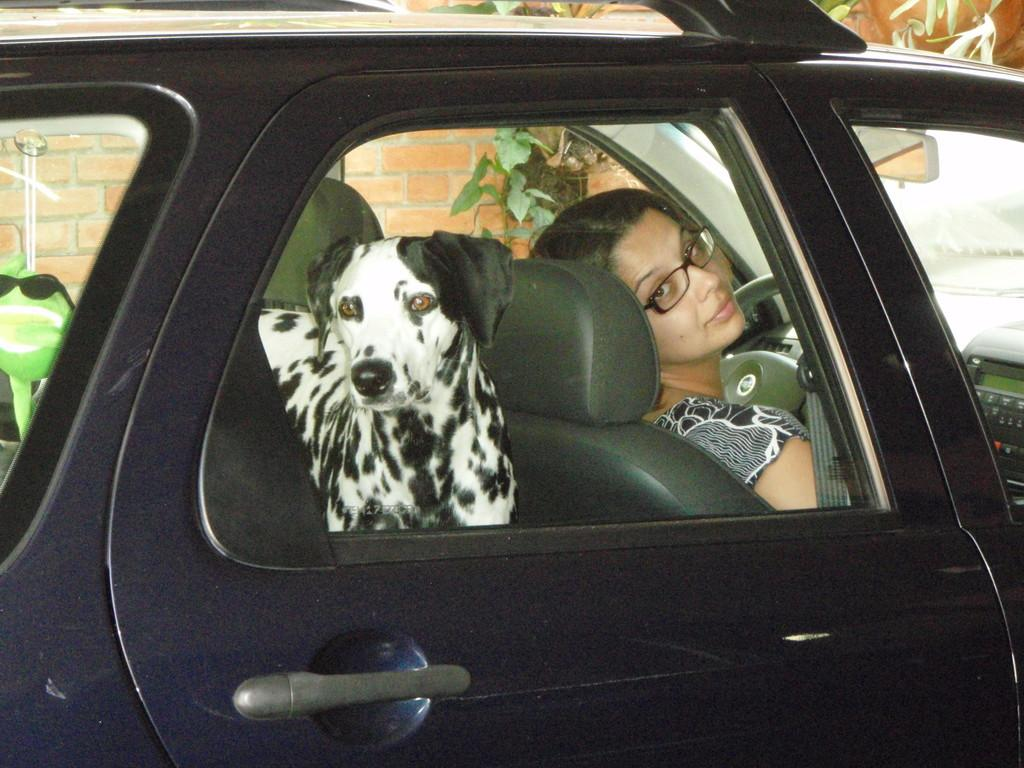What is the main subject of the image? There is a car in the image. Who is inside the car? A lady is sitting in the car. Can you describe the lady's appearance? The lady is wearing spectacles. What else can be seen in the car? There is a dog behind the lady in the car. What is present outside the car? There is a plant in the image. What type of locket is the lady wearing in the image? There is no mention of a locket in the image; the lady is wearing spectacles. Can you tell me the route the car is taking in the image? The image does not provide information about the car's route; it only shows the car and its occupants. 